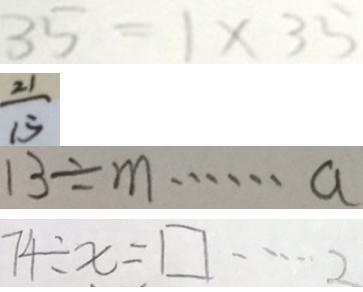<formula> <loc_0><loc_0><loc_500><loc_500>3 5 = 1 \times 3 5 
 \frac { 2 1 } { 1 5 } 
 1 3 \div m \cdots a 
 7 4 \div x = \square \cdots 2</formula> 